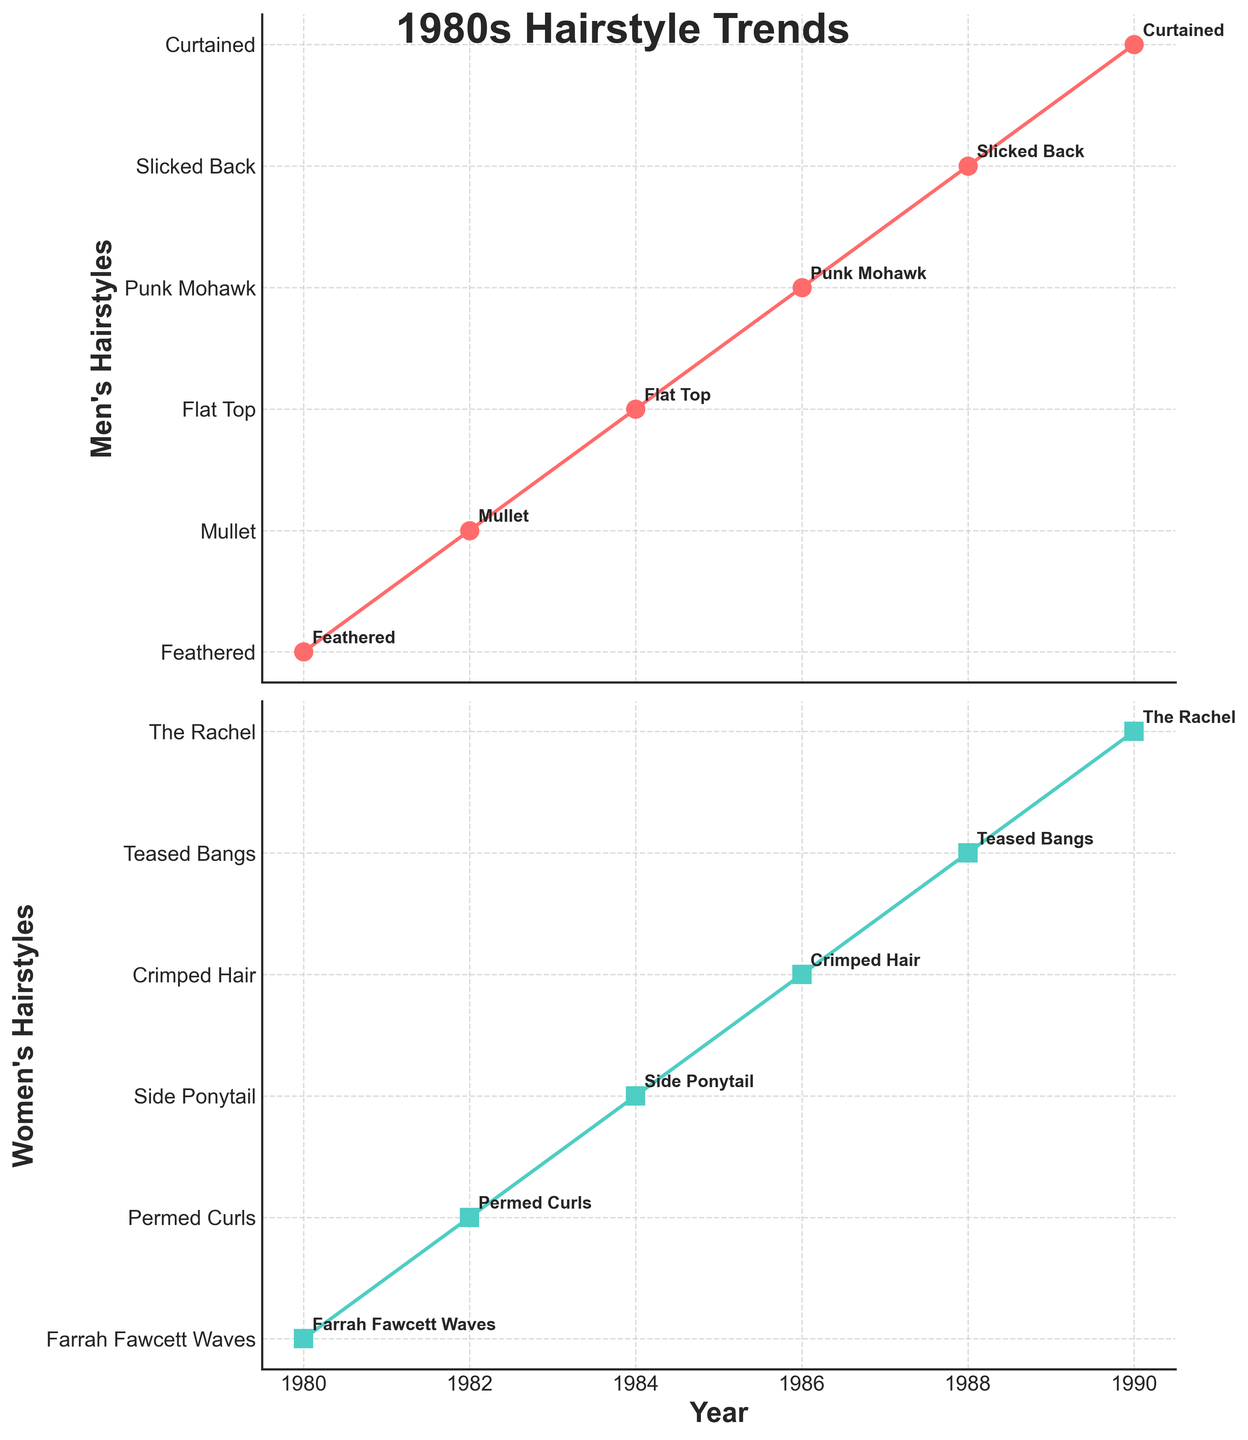What is the title of the figure? The title is located at the top center of the figure and clearly states the main theme of the plots.
Answer: 1980s Hairstyle Trends Which hairstyle is depicted for men in 1982? The men’s hairstlye for each year is plotted in the top subplot and each point is annotated with the respective hairstyle.
Answer: Mullet Which year had the "Crimped Hair" trend for women? The women's hairstyles for each year are plotted in the bottom subplot and each point is labeled. Crimped Hair corresponds to 1986.
Answer: 1986 How many years of data are represented in the figure? Count the number of data points (years) along the x-axis common to both subplots.
Answer: 6 years Which hairstyle for men was popular in 1988? Look at the data point for 1988 in the top subplot and check the annotation.
Answer: Slicked Back What is the trend in men's hairstyles from 1980 to 1990? Observe the sequence of data points and annotations in the top subplot from 1980 to 1990. There is a noticeable shift from long and styled looks like Feathered to shorter or more refined styles like Curtained.
Answer: Varied from Feathered to Curtained Compare the hairstyle trends for men and women in 1986. Check the 1986 data points in both subplots; for men, it is the Punk Mohawk and for women, it is Crimped Hair.
Answer: Punk Mohawk (men) vs. Crimped Hair (women) Which year had a Flat Top hairstyle for men, and what was the women's hairstyle that year? Identify the year with a Flat Top in the top subplot and find the same year in the bottom subplot for the corresponding value. That year, 1984, had a Side Ponytail for women.
Answer: 1984, Side Ponytail Identify the most distinct hairstyle change for women between two consecutive years. Evaluating the bottom subplot for significant hairstyle changes year-over-year, the switch from Crimped Hair in 1986 to Teased Bangs in 1988 appears distinct.
Answer: From Crimped Hair (1986) to Teased Bangs (1988) Determine the number of distinct women's hairstyles represented in the plot. Count the unique labels in the bottom subplot's annotations. There are 6 hairstyles: Farrah Fawcett Waves, Permed Curls, Side Ponytail, Crimped Hair, Teased Bangs, and The Rachel.
Answer: 6 distinct styles 